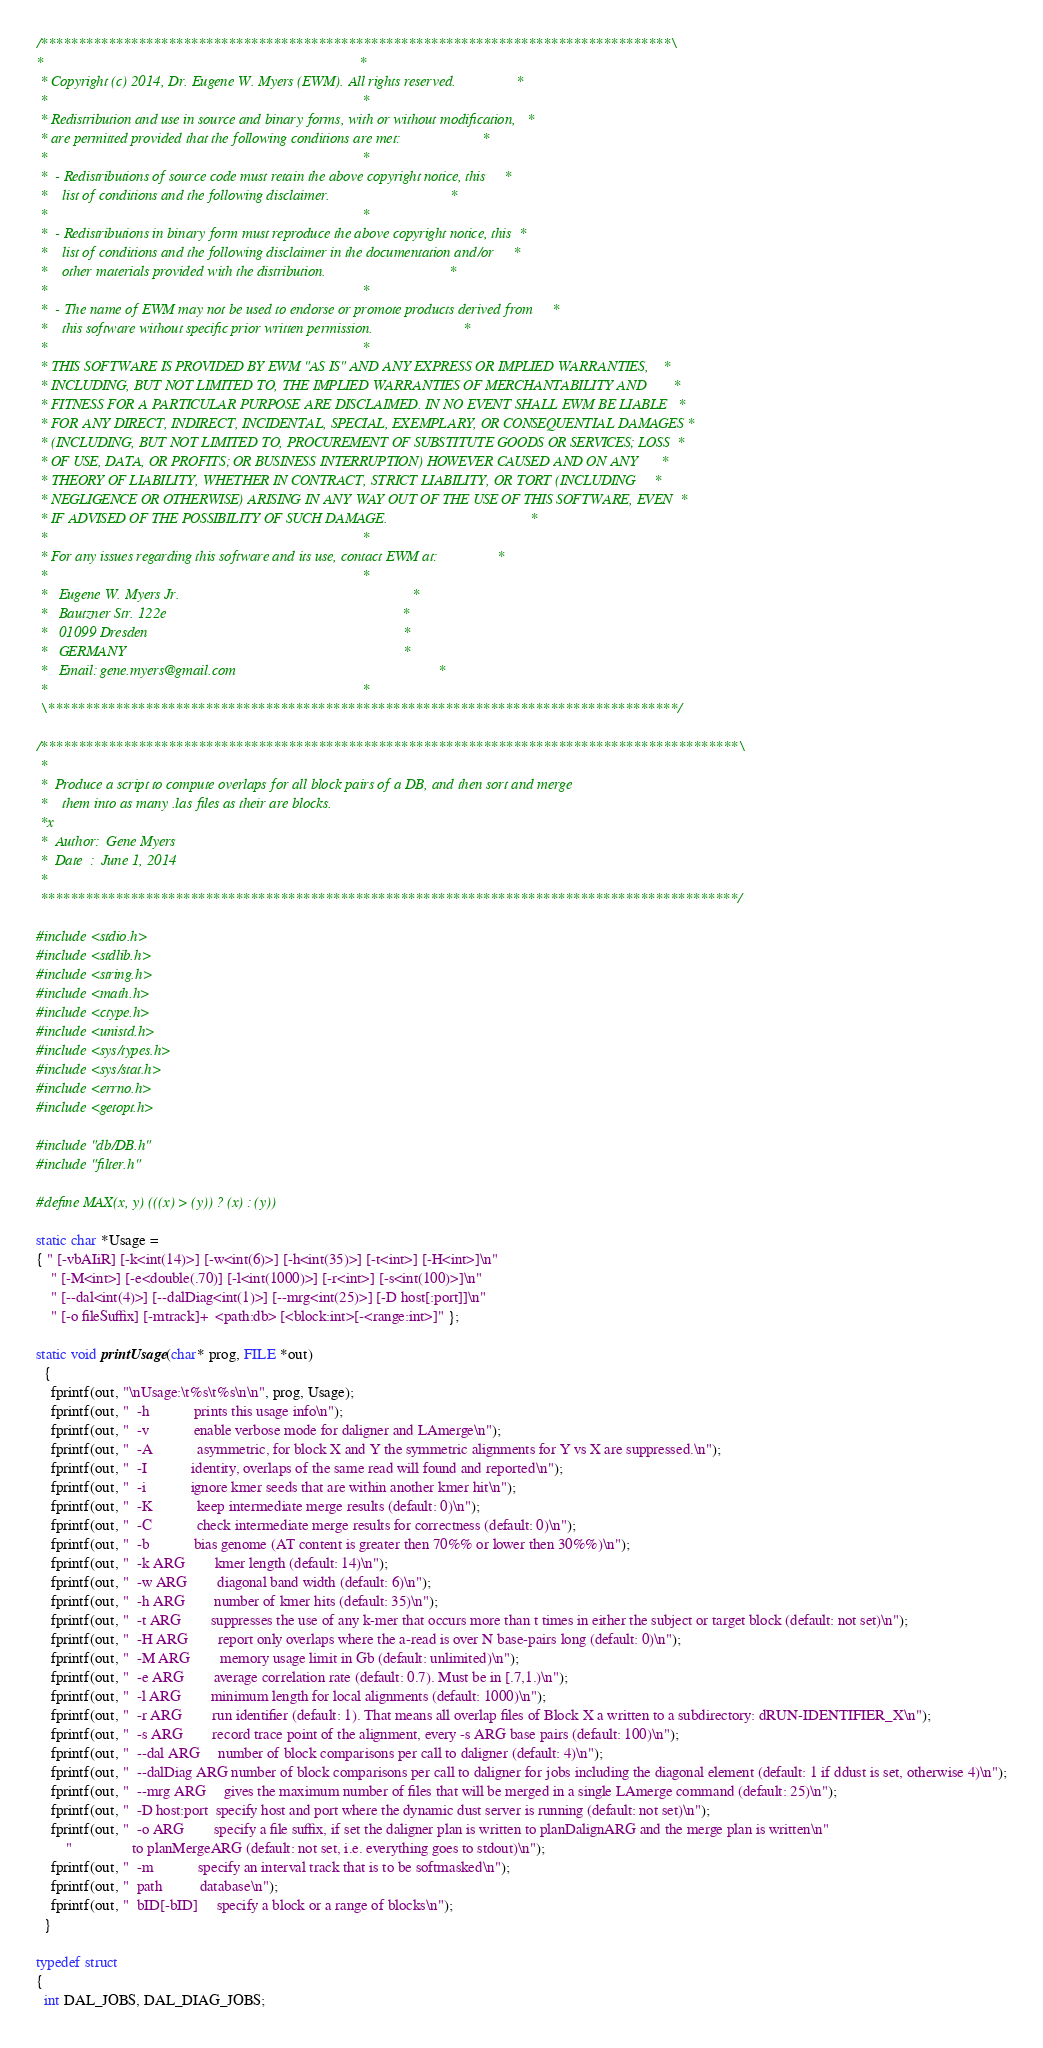<code> <loc_0><loc_0><loc_500><loc_500><_C_>/************************************************************************************\
*                                                                                    *
 * Copyright (c) 2014, Dr. Eugene W. Myers (EWM). All rights reserved.                *
 *                                                                                    *
 * Redistribution and use in source and binary forms, with or without modification,   *
 * are permitted provided that the following conditions are met:                      *
 *                                                                                    *
 *  - Redistributions of source code must retain the above copyright notice, this     *
 *    list of conditions and the following disclaimer.                                *
 *                                                                                    *
 *  - Redistributions in binary form must reproduce the above copyright notice, this  *
 *    list of conditions and the following disclaimer in the documentation and/or     *
 *    other materials provided with the distribution.                                 *
 *                                                                                    *
 *  - The name of EWM may not be used to endorse or promote products derived from     *
 *    this software without specific prior written permission.                        *
 *                                                                                    *
 * THIS SOFTWARE IS PROVIDED BY EWM "AS IS" AND ANY EXPRESS OR IMPLIED WARRANTIES,    *
 * INCLUDING, BUT NOT LIMITED TO, THE IMPLIED WARRANTIES OF MERCHANTABILITY AND       *
 * FITNESS FOR A PARTICULAR PURPOSE ARE DISCLAIMED. IN NO EVENT SHALL EWM BE LIABLE   *
 * FOR ANY DIRECT, INDIRECT, INCIDENTAL, SPECIAL, EXEMPLARY, OR CONSEQUENTIAL DAMAGES *
 * (INCLUDING, BUT NOT LIMITED TO, PROCUREMENT OF SUBSTITUTE GOODS OR SERVICES; LOSS  *
 * OF USE, DATA, OR PROFITS; OR BUSINESS INTERRUPTION) HOWEVER CAUSED AND ON ANY      *
 * THEORY OF LIABILITY, WHETHER IN CONTRACT, STRICT LIABILITY, OR TORT (INCLUDING     *
 * NEGLIGENCE OR OTHERWISE) ARISING IN ANY WAY OUT OF THE USE OF THIS SOFTWARE, EVEN  *
 * IF ADVISED OF THE POSSIBILITY OF SUCH DAMAGE.                                      *
 *                                                                                    *
 * For any issues regarding this software and its use, contact EWM at:                *
 *                                                                                    *
 *   Eugene W. Myers Jr.                                                              *
 *   Bautzner Str. 122e                                                               *
 *   01099 Dresden                                                                    *
 *   GERMANY                                                                          *
 *   Email: gene.myers@gmail.com                                                      *
 *                                                                                    *
 \************************************************************************************/

/*********************************************************************************************\
 *
 *  Produce a script to compute overlaps for all block pairs of a DB, and then sort and merge
 *    them into as many .las files as their are blocks.
 *x
 *  Author:  Gene Myers
 *  Date  :  June 1, 2014
 *
 *********************************************************************************************/

#include <stdio.h>
#include <stdlib.h>
#include <string.h>
#include <math.h>
#include <ctype.h>
#include <unistd.h>
#include <sys/types.h>
#include <sys/stat.h>
#include <errno.h>
#include <getopt.h>

#include "db/DB.h"
#include "filter.h"

#define MAX(x, y) (((x) > (y)) ? (x) : (y))

static char *Usage =
{ " [-vbAIiR] [-k<int(14)>] [-w<int(6)>] [-h<int(35)>] [-t<int>] [-H<int>]\n"
    " [-M<int>] [-e<double(.70)] [-l<int(1000)>] [-r<int>] [-s<int(100)>]\n"
    " [--dal<int(4)>] [--dalDiag<int(1)>] [--mrg<int(25)>] [-D host[:port]]\n"
    " [-o fileSuffix] [-mtrack]+  <path:db> [<block:int>[-<range:int>]" };

static void printUsage(char* prog, FILE *out)
  {
    fprintf(out, "\nUsage:\t%s\t%s\n\n", prog, Usage);
    fprintf(out, "  -h            prints this usage info\n");
    fprintf(out, "  -v            enable verbose mode for daligner and LAmerge\n");
    fprintf(out, "  -A            asymmetric, for block X and Y the symmetric alignments for Y vs X are suppressed.\n");
    fprintf(out, "  -I            identity, overlaps of the same read will found and reported\n");
    fprintf(out, "  -i            ignore kmer seeds that are within another kmer hit\n");
    fprintf(out, "  -K            keep intermediate merge results (default: 0)\n");
    fprintf(out, "  -C            check intermediate merge results for correctness (default: 0)\n");
    fprintf(out, "  -b            bias genome (AT content is greater then 70%% or lower then 30%%)\n");
    fprintf(out, "  -k ARG        kmer length (default: 14)\n");
    fprintf(out, "  -w ARG        diagonal band width (default: 6)\n");
    fprintf(out, "  -h ARG        number of kmer hits (default: 35)\n");
    fprintf(out, "  -t ARG        suppresses the use of any k-mer that occurs more than t times in either the subject or target block (default: not set)\n");
    fprintf(out, "  -H ARG        report only overlaps where the a-read is over N base-pairs long (default: 0)\n");
    fprintf(out, "  -M ARG        memory usage limit in Gb (default: unlimited)\n");
    fprintf(out, "  -e ARG        average correlation rate (default: 0.7). Must be in [.7,1.)\n");
    fprintf(out, "  -l ARG        minimum length for local alignments (default: 1000)\n");
    fprintf(out, "  -r ARG        run identifier (default: 1). That means all overlap files of Block X a written to a subdirectory: dRUN-IDENTIFIER_X\n");
    fprintf(out, "  -s ARG        record trace point of the alignment, every -s ARG base pairs (default: 100)\n");
    fprintf(out, "  --dal ARG     number of block comparisons per call to daligner (default: 4)\n");
    fprintf(out, "  --dalDiag ARG number of block comparisons per call to daligner for jobs including the diagonal element (default: 1 if ddust is set, otherwise 4)\n");
    fprintf(out, "  --mrg ARG     gives the maximum number of files that will be merged in a single LAmerge command (default: 25)\n");
    fprintf(out, "  -D host:port  specify host and port where the dynamic dust server is running (default: not set)\n");
    fprintf(out, "  -o ARG        specify a file suffix, if set the daligner plan is written to planDalignARG and the merge plan is written\n"
        "                to planMergeARG (default: not set, i.e. everything goes to stdout)\n");
    fprintf(out, "  -m            specify an interval track that is to be softmasked\n");
    fprintf(out, "  path          database\n");
    fprintf(out, "  bID[-bID]     specify a block or a range of blocks\n");
  }

typedef struct
{
  int DAL_JOBS, DAL_DIAG_JOBS;</code> 